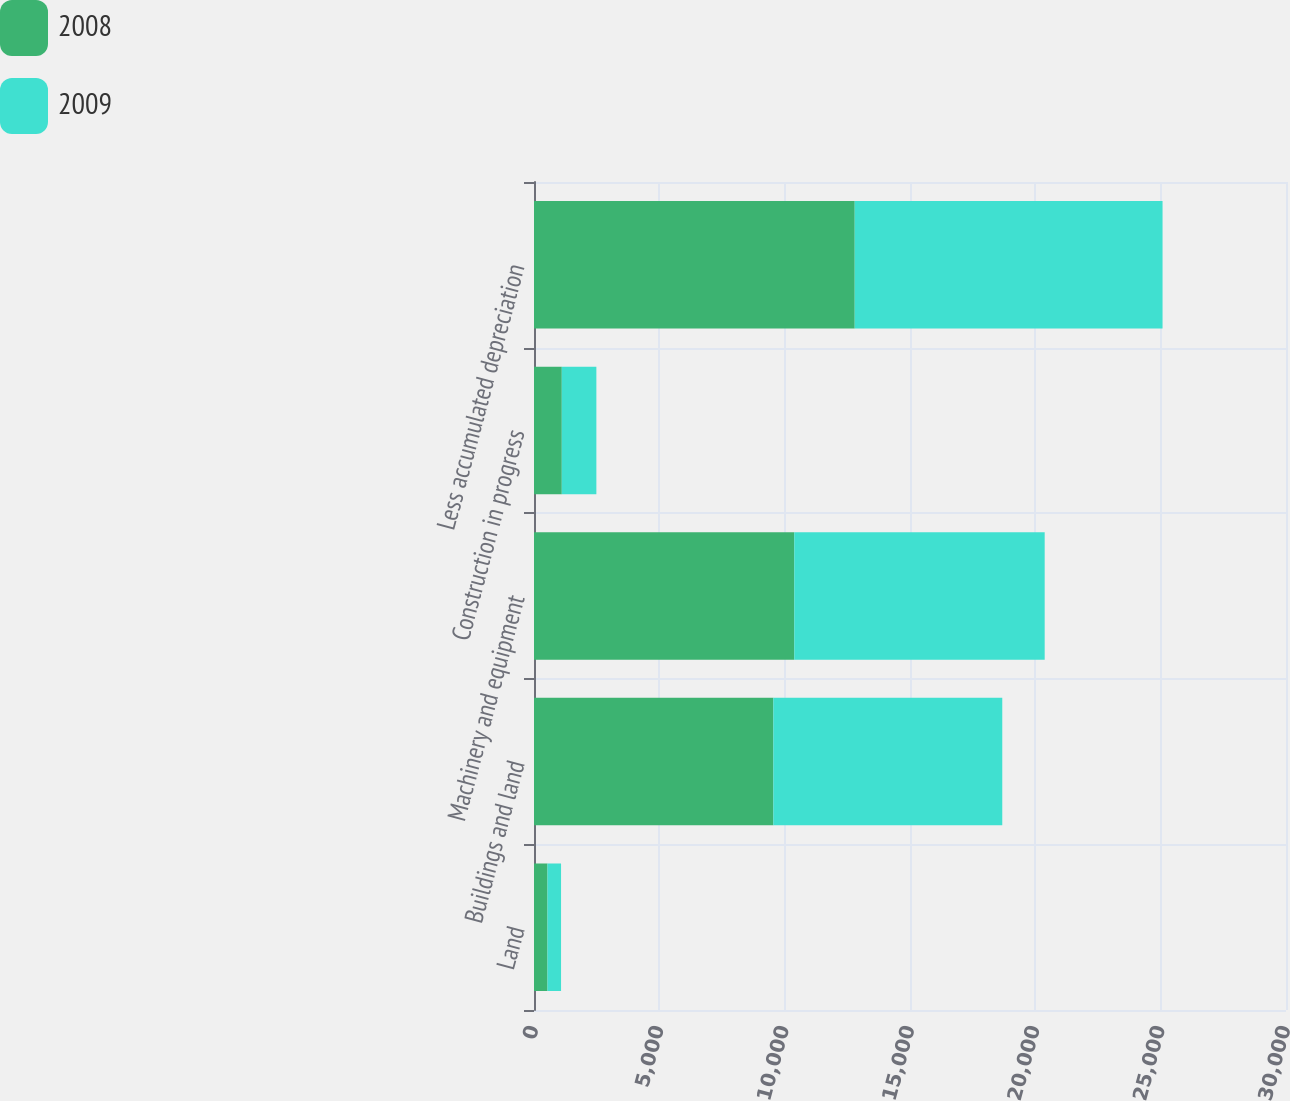<chart> <loc_0><loc_0><loc_500><loc_500><stacked_bar_chart><ecel><fcel>Land<fcel>Buildings and land<fcel>Machinery and equipment<fcel>Construction in progress<fcel>Less accumulated depreciation<nl><fcel>2008<fcel>539<fcel>9548<fcel>10383<fcel>1109<fcel>12795<nl><fcel>2009<fcel>540<fcel>9133<fcel>9990<fcel>1379<fcel>12280<nl></chart> 